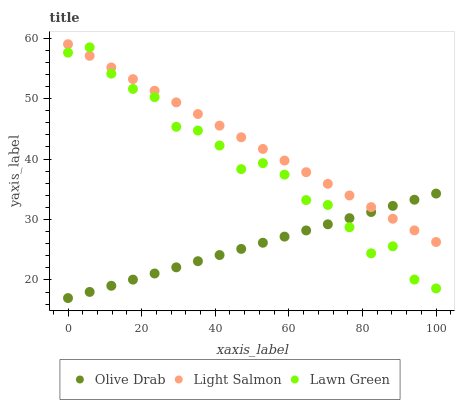Does Olive Drab have the minimum area under the curve?
Answer yes or no. Yes. Does Light Salmon have the maximum area under the curve?
Answer yes or no. Yes. Does Light Salmon have the minimum area under the curve?
Answer yes or no. No. Does Olive Drab have the maximum area under the curve?
Answer yes or no. No. Is Olive Drab the smoothest?
Answer yes or no. Yes. Is Lawn Green the roughest?
Answer yes or no. Yes. Is Light Salmon the smoothest?
Answer yes or no. No. Is Light Salmon the roughest?
Answer yes or no. No. Does Olive Drab have the lowest value?
Answer yes or no. Yes. Does Light Salmon have the lowest value?
Answer yes or no. No. Does Light Salmon have the highest value?
Answer yes or no. Yes. Does Olive Drab have the highest value?
Answer yes or no. No. Does Light Salmon intersect Olive Drab?
Answer yes or no. Yes. Is Light Salmon less than Olive Drab?
Answer yes or no. No. Is Light Salmon greater than Olive Drab?
Answer yes or no. No. 